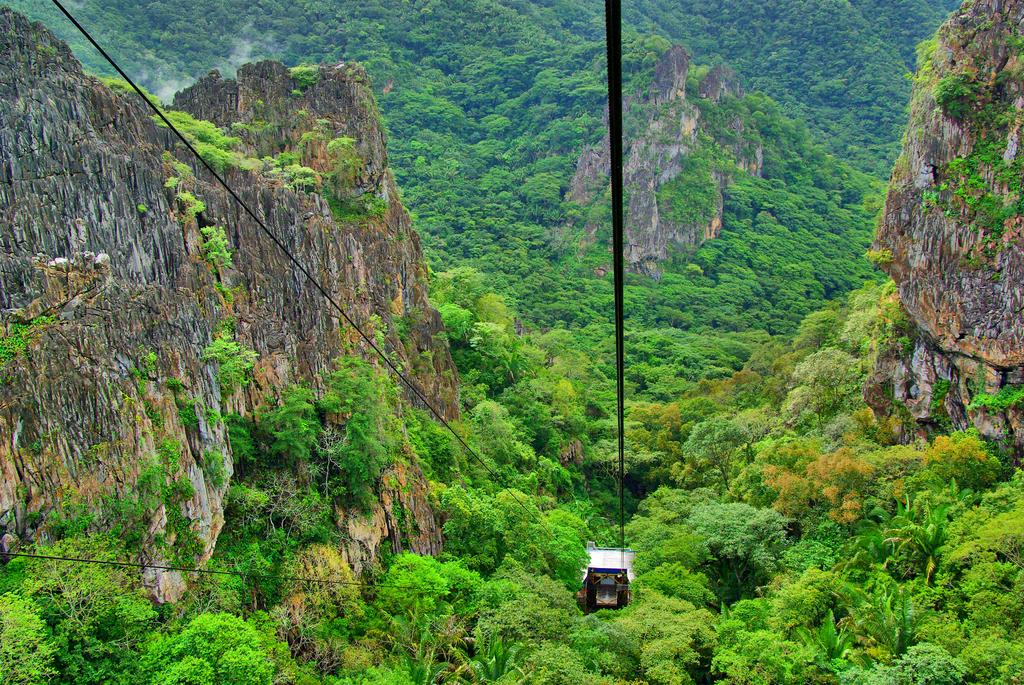What type of natural vegetation is present in the image? There are trees in the image. What type of geological formation can be seen in the image? There are mountains in the image. What mode of transportation is visible in the image? There is a cable car at the center of the image. Can you see a swing in the image? There is no swing present in the image. Is it raining in the image? The image does not provide any information about the weather, so it cannot be determined if it is raining. 